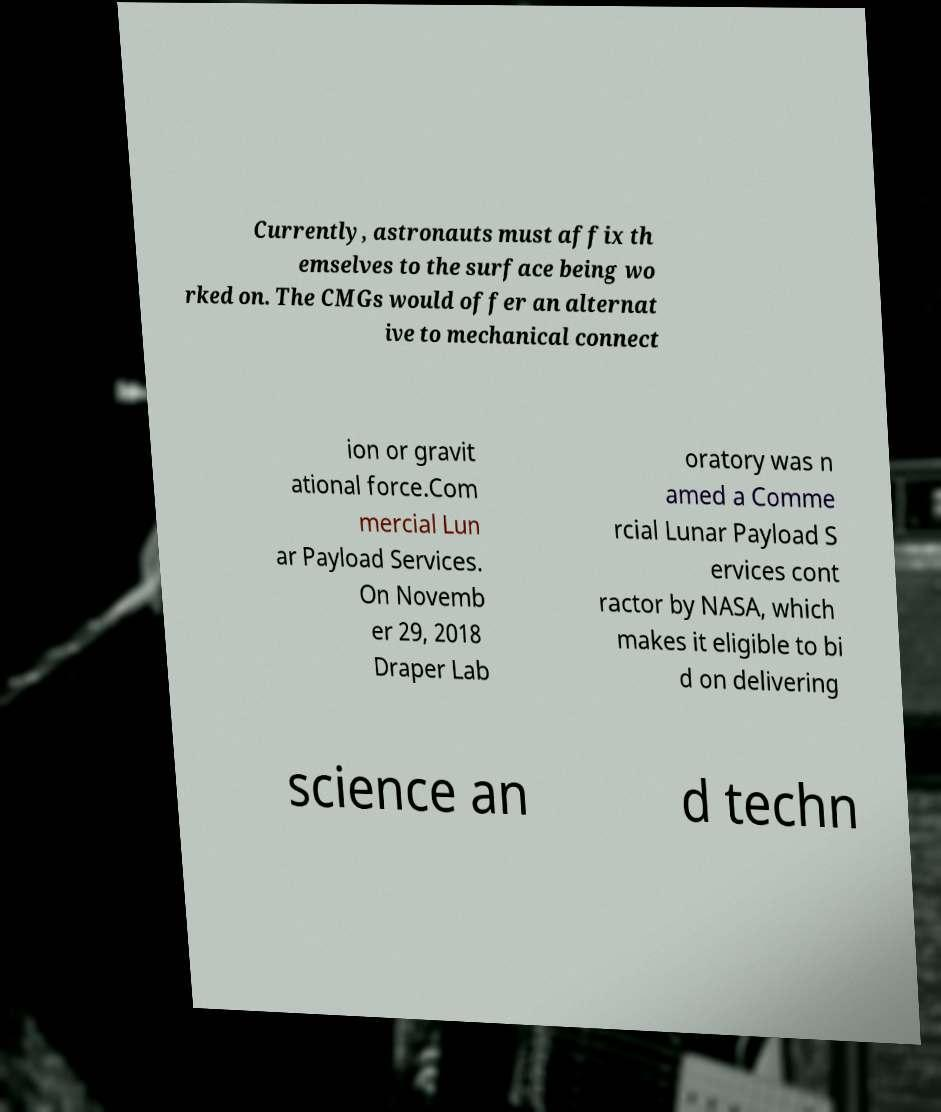What messages or text are displayed in this image? I need them in a readable, typed format. Currently, astronauts must affix th emselves to the surface being wo rked on. The CMGs would offer an alternat ive to mechanical connect ion or gravit ational force.Com mercial Lun ar Payload Services. On Novemb er 29, 2018 Draper Lab oratory was n amed a Comme rcial Lunar Payload S ervices cont ractor by NASA, which makes it eligible to bi d on delivering science an d techn 